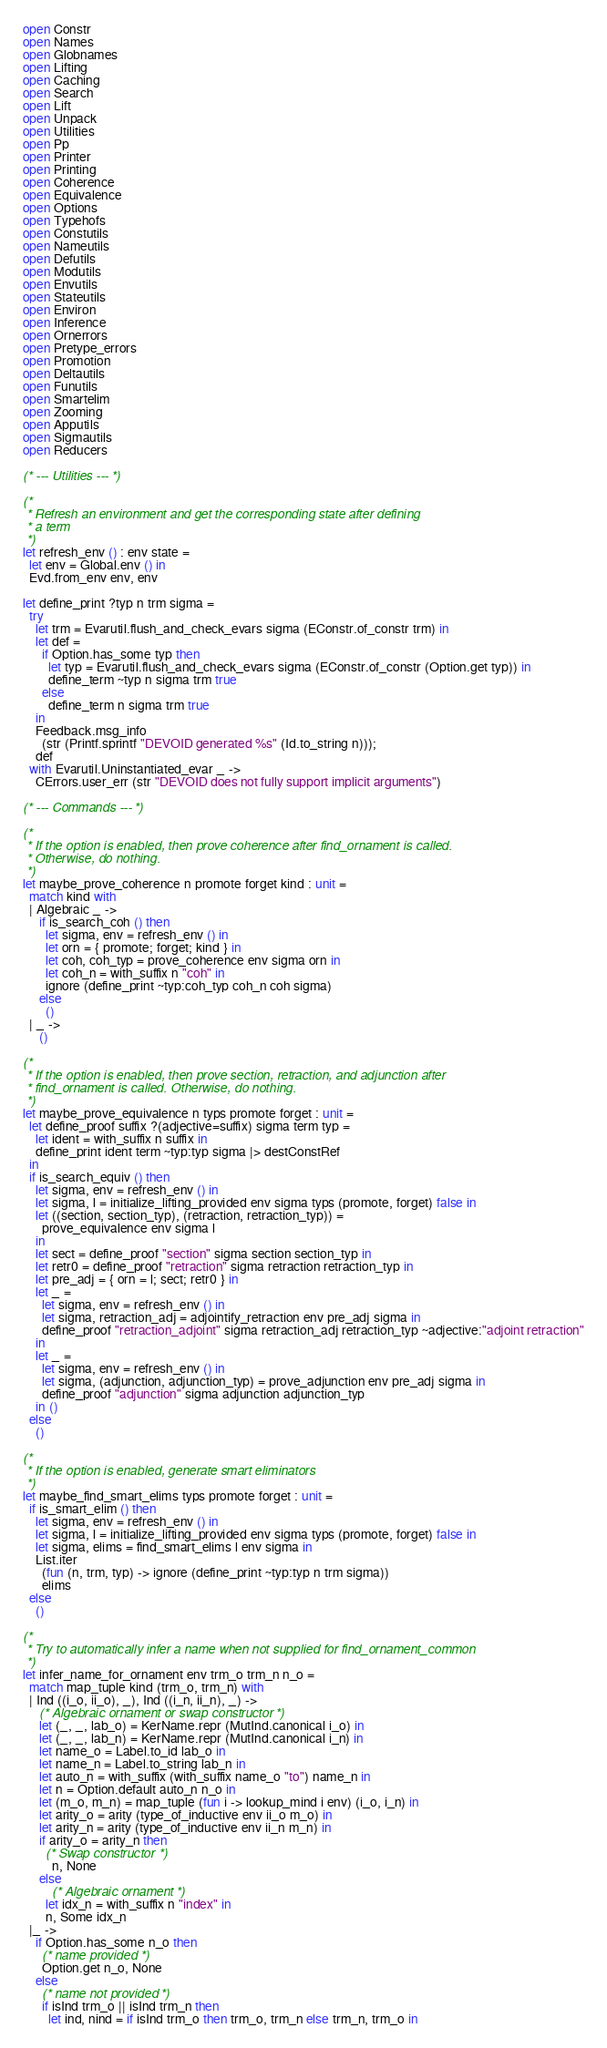Convert code to text. <code><loc_0><loc_0><loc_500><loc_500><_OCaml_>open Constr
open Names
open Globnames
open Lifting
open Caching
open Search
open Lift
open Unpack
open Utilities
open Pp
open Printer
open Printing
open Coherence
open Equivalence
open Options
open Typehofs
open Constutils
open Nameutils
open Defutils
open Modutils
open Envutils
open Stateutils
open Environ
open Inference
open Ornerrors
open Pretype_errors
open Promotion
open Deltautils
open Funutils
open Smartelim
open Zooming
open Apputils
open Sigmautils
open Reducers

(* --- Utilities --- *)

(*
 * Refresh an environment and get the corresponding state after defining
 * a term
 *)
let refresh_env () : env state =
  let env = Global.env () in
  Evd.from_env env, env

let define_print ?typ n trm sigma =
  try
    let trm = Evarutil.flush_and_check_evars sigma (EConstr.of_constr trm) in
    let def =
      if Option.has_some typ then
        let typ = Evarutil.flush_and_check_evars sigma (EConstr.of_constr (Option.get typ)) in
        define_term ~typ n sigma trm true
      else
        define_term n sigma trm true
    in
    Feedback.msg_info
      (str (Printf.sprintf "DEVOID generated %s" (Id.to_string n)));
    def
  with Evarutil.Uninstantiated_evar _ ->
    CErrors.user_err (str "DEVOID does not fully support implicit arguments")

(* --- Commands --- *)

(*
 * If the option is enabled, then prove coherence after find_ornament is called.
 * Otherwise, do nothing.
 *)
let maybe_prove_coherence n promote forget kind : unit =
  match kind with
  | Algebraic _ ->
     if is_search_coh () then
       let sigma, env = refresh_env () in
       let orn = { promote; forget; kind } in
       let coh, coh_typ = prove_coherence env sigma orn in
       let coh_n = with_suffix n "coh" in
       ignore (define_print ~typ:coh_typ coh_n coh sigma)
     else
       ()
  | _ ->
     ()

(*
 * If the option is enabled, then prove section, retraction, and adjunction after
 * find_ornament is called. Otherwise, do nothing.
 *)
let maybe_prove_equivalence n typs promote forget : unit =
  let define_proof suffix ?(adjective=suffix) sigma term typ =
    let ident = with_suffix n suffix in
    define_print ident term ~typ:typ sigma |> destConstRef
  in
  if is_search_equiv () then
    let sigma, env = refresh_env () in
    let sigma, l = initialize_lifting_provided env sigma typs (promote, forget) false in
    let ((section, section_typ), (retraction, retraction_typ)) =
      prove_equivalence env sigma l
    in
    let sect = define_proof "section" sigma section section_typ in
    let retr0 = define_proof "retraction" sigma retraction retraction_typ in
    let pre_adj = { orn = l; sect; retr0 } in
    let _ =
      let sigma, env = refresh_env () in
      let sigma, retraction_adj = adjointify_retraction env pre_adj sigma in
      define_proof "retraction_adjoint" sigma retraction_adj retraction_typ ~adjective:"adjoint retraction"
    in
    let _ =
      let sigma, env = refresh_env () in
      let sigma, (adjunction, adjunction_typ) = prove_adjunction env pre_adj sigma in
      define_proof "adjunction" sigma adjunction adjunction_typ
    in ()
  else
    ()

(*
 * If the option is enabled, generate smart eliminators
 *)
let maybe_find_smart_elims typs promote forget : unit =
  if is_smart_elim () then
    let sigma, env = refresh_env () in
    let sigma, l = initialize_lifting_provided env sigma typs (promote, forget) false in
    let sigma, elims = find_smart_elims l env sigma in
    List.iter
      (fun (n, trm, typ) -> ignore (define_print ~typ:typ n trm sigma))
      elims
  else
    ()

(*
 * Try to automatically infer a name when not supplied for find_ornament_common
 *)
let infer_name_for_ornament env trm_o trm_n n_o =
  match map_tuple kind (trm_o, trm_n) with
  | Ind ((i_o, ii_o), _), Ind ((i_n, ii_n), _) ->
     (* Algebraic ornament or swap constructor *)
     let (_, _, lab_o) = KerName.repr (MutInd.canonical i_o) in
     let (_, _, lab_n) = KerName.repr (MutInd.canonical i_n) in
     let name_o = Label.to_id lab_o in
     let name_n = Label.to_string lab_n in
     let auto_n = with_suffix (with_suffix name_o "to") name_n in
     let n = Option.default auto_n n_o in
     let (m_o, m_n) = map_tuple (fun i -> lookup_mind i env) (i_o, i_n) in
     let arity_o = arity (type_of_inductive env ii_o m_o) in
     let arity_n = arity (type_of_inductive env ii_n m_n) in
     if arity_o = arity_n then
       (* Swap constructor *)
         n, None
     else
         (* Algebraic ornament *)
       let idx_n = with_suffix n "index" in
       n, Some idx_n
  |_ ->
    if Option.has_some n_o then
      (* name provided *)
      Option.get n_o, None
    else
      (* name not provided *)
      if isInd trm_o || isInd trm_n then
        let ind, nind = if isInd trm_o then trm_o, trm_n else trm_n, trm_o in</code> 